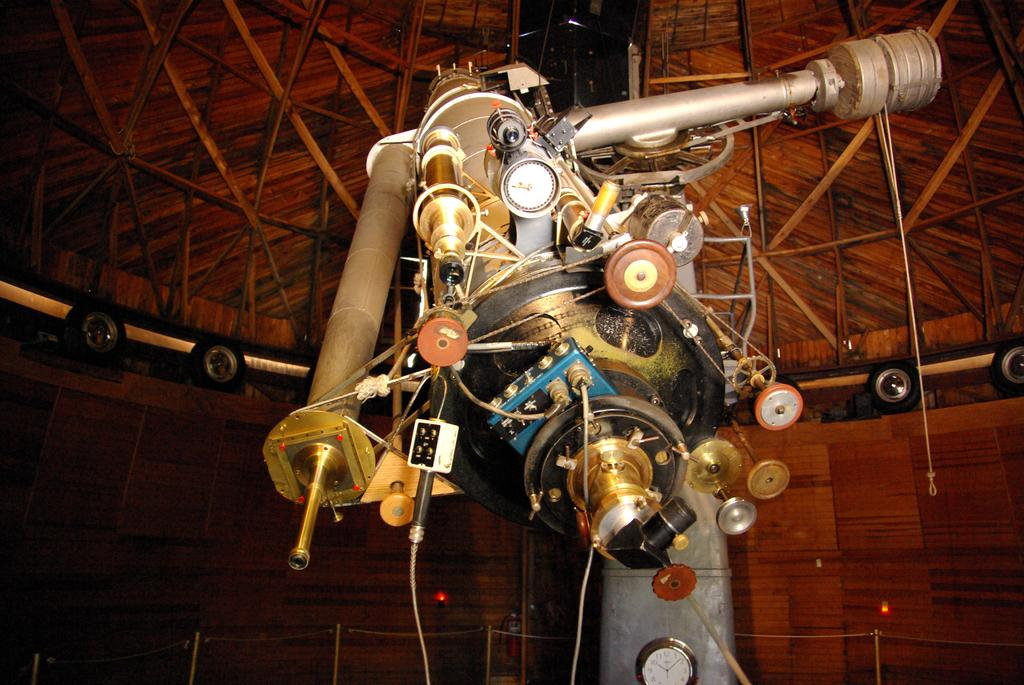What is the main structure visible in the image? The main structure visible in the image is a dome. What is located inside the dome? There is an equipment present inside the dome. How does the soap inside the dome help the son in the image? There is no soap or son present in the image; it only features a dome with equipment inside. 